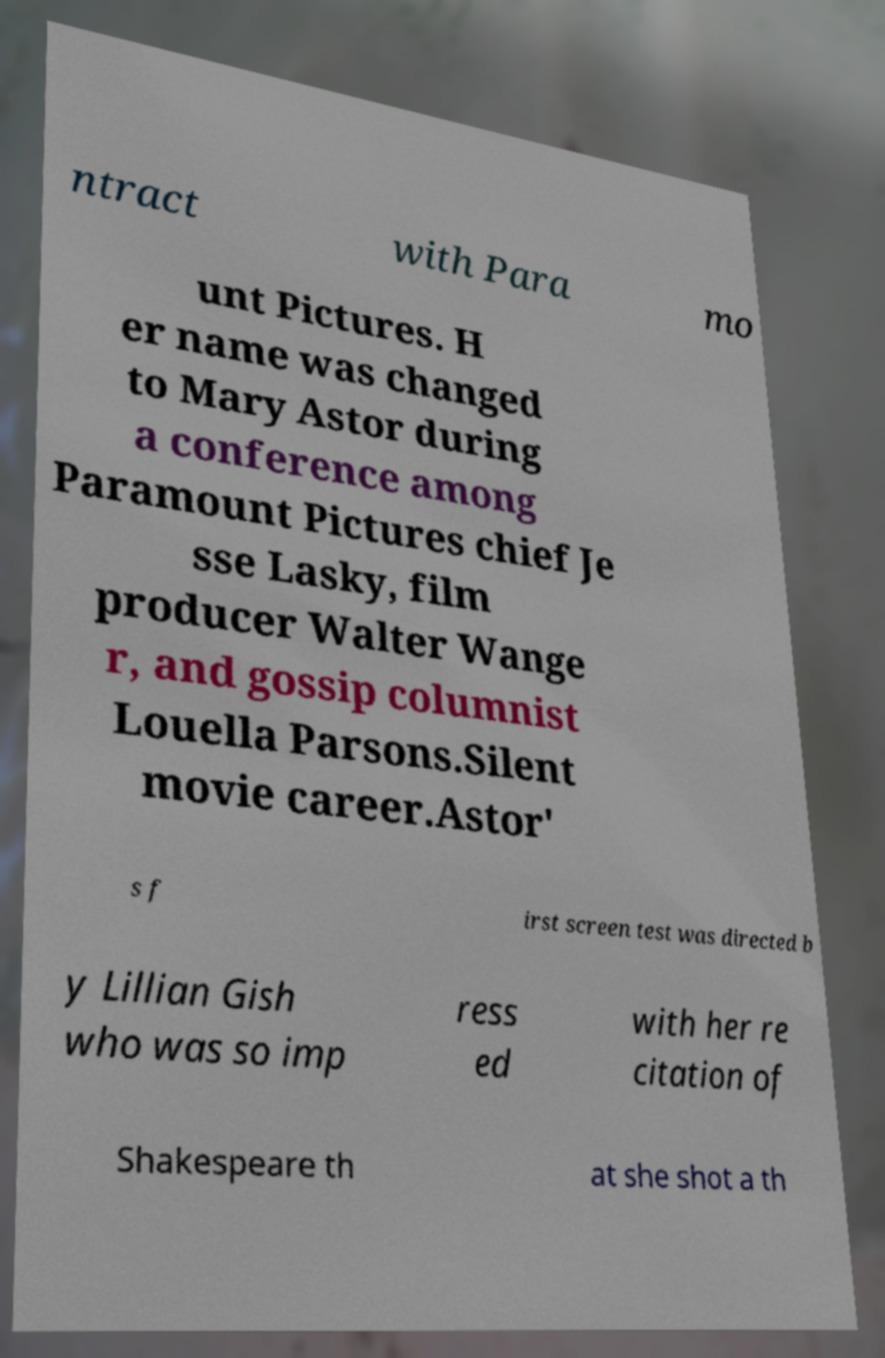For documentation purposes, I need the text within this image transcribed. Could you provide that? ntract with Para mo unt Pictures. H er name was changed to Mary Astor during a conference among Paramount Pictures chief Je sse Lasky, film producer Walter Wange r, and gossip columnist Louella Parsons.Silent movie career.Astor' s f irst screen test was directed b y Lillian Gish who was so imp ress ed with her re citation of Shakespeare th at she shot a th 